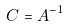<formula> <loc_0><loc_0><loc_500><loc_500>C = A ^ { - 1 }</formula> 